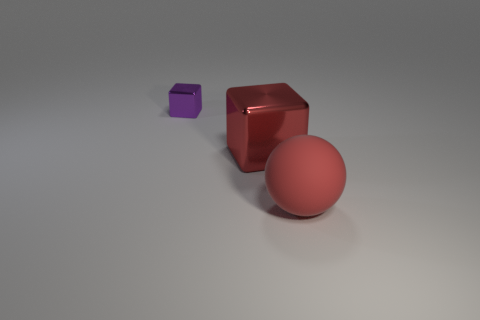Subtract all red cubes. How many cubes are left? 1 Subtract 1 balls. How many balls are left? 0 Subtract all rubber balls. Subtract all metal objects. How many objects are left? 0 Add 1 spheres. How many spheres are left? 2 Add 3 small red shiny cylinders. How many small red shiny cylinders exist? 3 Add 3 large purple matte cubes. How many objects exist? 6 Subtract 0 green balls. How many objects are left? 3 Subtract all cubes. How many objects are left? 1 Subtract all purple blocks. Subtract all brown cylinders. How many blocks are left? 1 Subtract all green balls. How many brown blocks are left? 0 